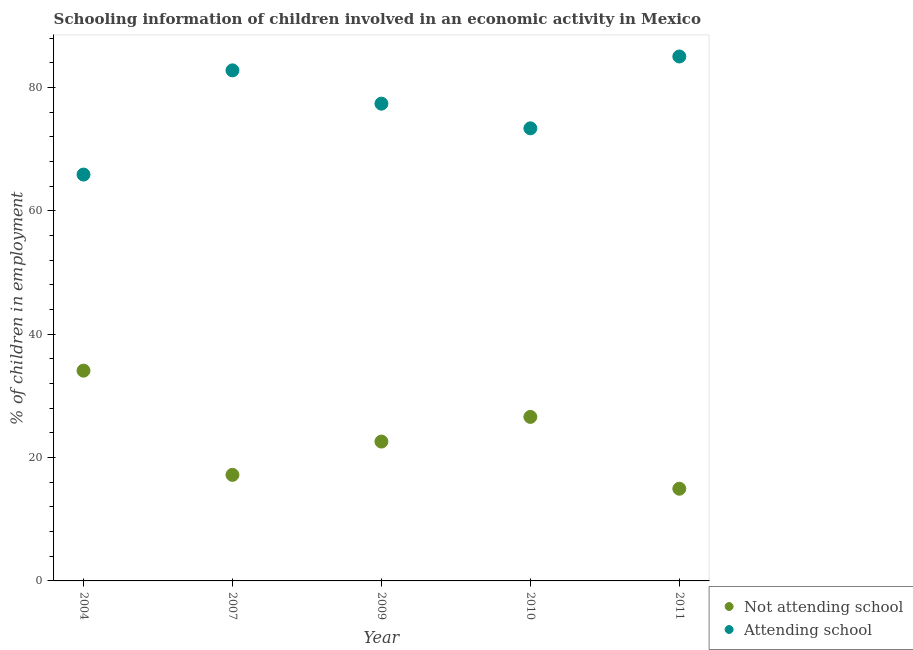How many different coloured dotlines are there?
Offer a very short reply. 2. Is the number of dotlines equal to the number of legend labels?
Ensure brevity in your answer.  Yes. What is the percentage of employed children who are not attending school in 2011?
Make the answer very short. 14.95. Across all years, what is the maximum percentage of employed children who are attending school?
Offer a terse response. 85.05. Across all years, what is the minimum percentage of employed children who are attending school?
Keep it short and to the point. 65.9. What is the total percentage of employed children who are attending school in the graph?
Your answer should be very brief. 384.55. What is the difference between the percentage of employed children who are not attending school in 2004 and that in 2007?
Offer a very short reply. 16.9. What is the difference between the percentage of employed children who are not attending school in 2010 and the percentage of employed children who are attending school in 2009?
Offer a very short reply. -50.8. What is the average percentage of employed children who are not attending school per year?
Your response must be concise. 23.09. In the year 2007, what is the difference between the percentage of employed children who are not attending school and percentage of employed children who are attending school?
Offer a very short reply. -65.6. In how many years, is the percentage of employed children who are attending school greater than 84 %?
Your answer should be compact. 1. What is the ratio of the percentage of employed children who are attending school in 2007 to that in 2009?
Your answer should be compact. 1.07. Is the percentage of employed children who are attending school in 2010 less than that in 2011?
Your answer should be very brief. Yes. What is the difference between the highest and the lowest percentage of employed children who are attending school?
Offer a very short reply. 19.15. Does the percentage of employed children who are attending school monotonically increase over the years?
Keep it short and to the point. No. Is the percentage of employed children who are attending school strictly less than the percentage of employed children who are not attending school over the years?
Your answer should be very brief. No. How many dotlines are there?
Ensure brevity in your answer.  2. How many years are there in the graph?
Offer a very short reply. 5. What is the difference between two consecutive major ticks on the Y-axis?
Provide a succinct answer. 20. Does the graph contain any zero values?
Provide a short and direct response. No. Does the graph contain grids?
Make the answer very short. No. What is the title of the graph?
Your answer should be very brief. Schooling information of children involved in an economic activity in Mexico. Does "Fraud firms" appear as one of the legend labels in the graph?
Offer a very short reply. No. What is the label or title of the X-axis?
Provide a short and direct response. Year. What is the label or title of the Y-axis?
Make the answer very short. % of children in employment. What is the % of children in employment of Not attending school in 2004?
Offer a very short reply. 34.1. What is the % of children in employment in Attending school in 2004?
Ensure brevity in your answer.  65.9. What is the % of children in employment of Not attending school in 2007?
Offer a terse response. 17.2. What is the % of children in employment of Attending school in 2007?
Your answer should be compact. 82.8. What is the % of children in employment in Not attending school in 2009?
Make the answer very short. 22.6. What is the % of children in employment in Attending school in 2009?
Provide a succinct answer. 77.4. What is the % of children in employment of Not attending school in 2010?
Your answer should be compact. 26.6. What is the % of children in employment of Attending school in 2010?
Offer a terse response. 73.4. What is the % of children in employment of Not attending school in 2011?
Ensure brevity in your answer.  14.95. What is the % of children in employment of Attending school in 2011?
Offer a very short reply. 85.05. Across all years, what is the maximum % of children in employment in Not attending school?
Your answer should be compact. 34.1. Across all years, what is the maximum % of children in employment in Attending school?
Provide a short and direct response. 85.05. Across all years, what is the minimum % of children in employment of Not attending school?
Ensure brevity in your answer.  14.95. Across all years, what is the minimum % of children in employment of Attending school?
Provide a succinct answer. 65.9. What is the total % of children in employment in Not attending school in the graph?
Provide a succinct answer. 115.45. What is the total % of children in employment in Attending school in the graph?
Offer a terse response. 384.55. What is the difference between the % of children in employment in Attending school in 2004 and that in 2007?
Offer a terse response. -16.9. What is the difference between the % of children in employment in Not attending school in 2004 and that in 2010?
Your answer should be very brief. 7.5. What is the difference between the % of children in employment of Attending school in 2004 and that in 2010?
Offer a terse response. -7.5. What is the difference between the % of children in employment of Not attending school in 2004 and that in 2011?
Your answer should be compact. 19.15. What is the difference between the % of children in employment of Attending school in 2004 and that in 2011?
Give a very brief answer. -19.15. What is the difference between the % of children in employment of Not attending school in 2007 and that in 2009?
Provide a succinct answer. -5.4. What is the difference between the % of children in employment in Not attending school in 2007 and that in 2011?
Keep it short and to the point. 2.25. What is the difference between the % of children in employment in Attending school in 2007 and that in 2011?
Provide a short and direct response. -2.25. What is the difference between the % of children in employment of Not attending school in 2009 and that in 2010?
Offer a terse response. -4. What is the difference between the % of children in employment of Not attending school in 2009 and that in 2011?
Make the answer very short. 7.65. What is the difference between the % of children in employment in Attending school in 2009 and that in 2011?
Provide a succinct answer. -7.65. What is the difference between the % of children in employment of Not attending school in 2010 and that in 2011?
Keep it short and to the point. 11.65. What is the difference between the % of children in employment of Attending school in 2010 and that in 2011?
Keep it short and to the point. -11.65. What is the difference between the % of children in employment of Not attending school in 2004 and the % of children in employment of Attending school in 2007?
Give a very brief answer. -48.7. What is the difference between the % of children in employment of Not attending school in 2004 and the % of children in employment of Attending school in 2009?
Your answer should be very brief. -43.3. What is the difference between the % of children in employment in Not attending school in 2004 and the % of children in employment in Attending school in 2010?
Make the answer very short. -39.3. What is the difference between the % of children in employment in Not attending school in 2004 and the % of children in employment in Attending school in 2011?
Provide a succinct answer. -50.95. What is the difference between the % of children in employment in Not attending school in 2007 and the % of children in employment in Attending school in 2009?
Provide a succinct answer. -60.2. What is the difference between the % of children in employment in Not attending school in 2007 and the % of children in employment in Attending school in 2010?
Your answer should be very brief. -56.2. What is the difference between the % of children in employment in Not attending school in 2007 and the % of children in employment in Attending school in 2011?
Provide a succinct answer. -67.85. What is the difference between the % of children in employment of Not attending school in 2009 and the % of children in employment of Attending school in 2010?
Provide a short and direct response. -50.8. What is the difference between the % of children in employment of Not attending school in 2009 and the % of children in employment of Attending school in 2011?
Make the answer very short. -62.45. What is the difference between the % of children in employment of Not attending school in 2010 and the % of children in employment of Attending school in 2011?
Your answer should be very brief. -58.45. What is the average % of children in employment of Not attending school per year?
Provide a short and direct response. 23.09. What is the average % of children in employment of Attending school per year?
Offer a terse response. 76.91. In the year 2004, what is the difference between the % of children in employment of Not attending school and % of children in employment of Attending school?
Offer a terse response. -31.8. In the year 2007, what is the difference between the % of children in employment in Not attending school and % of children in employment in Attending school?
Your answer should be very brief. -65.6. In the year 2009, what is the difference between the % of children in employment in Not attending school and % of children in employment in Attending school?
Provide a short and direct response. -54.8. In the year 2010, what is the difference between the % of children in employment of Not attending school and % of children in employment of Attending school?
Offer a very short reply. -46.8. In the year 2011, what is the difference between the % of children in employment in Not attending school and % of children in employment in Attending school?
Provide a succinct answer. -70.1. What is the ratio of the % of children in employment in Not attending school in 2004 to that in 2007?
Offer a very short reply. 1.98. What is the ratio of the % of children in employment of Attending school in 2004 to that in 2007?
Provide a succinct answer. 0.8. What is the ratio of the % of children in employment of Not attending school in 2004 to that in 2009?
Your answer should be compact. 1.51. What is the ratio of the % of children in employment in Attending school in 2004 to that in 2009?
Provide a succinct answer. 0.85. What is the ratio of the % of children in employment of Not attending school in 2004 to that in 2010?
Your answer should be very brief. 1.28. What is the ratio of the % of children in employment of Attending school in 2004 to that in 2010?
Give a very brief answer. 0.9. What is the ratio of the % of children in employment of Not attending school in 2004 to that in 2011?
Ensure brevity in your answer.  2.28. What is the ratio of the % of children in employment in Attending school in 2004 to that in 2011?
Give a very brief answer. 0.77. What is the ratio of the % of children in employment of Not attending school in 2007 to that in 2009?
Ensure brevity in your answer.  0.76. What is the ratio of the % of children in employment in Attending school in 2007 to that in 2009?
Make the answer very short. 1.07. What is the ratio of the % of children in employment of Not attending school in 2007 to that in 2010?
Your answer should be compact. 0.65. What is the ratio of the % of children in employment in Attending school in 2007 to that in 2010?
Ensure brevity in your answer.  1.13. What is the ratio of the % of children in employment in Not attending school in 2007 to that in 2011?
Ensure brevity in your answer.  1.15. What is the ratio of the % of children in employment of Attending school in 2007 to that in 2011?
Offer a very short reply. 0.97. What is the ratio of the % of children in employment of Not attending school in 2009 to that in 2010?
Your response must be concise. 0.85. What is the ratio of the % of children in employment in Attending school in 2009 to that in 2010?
Make the answer very short. 1.05. What is the ratio of the % of children in employment in Not attending school in 2009 to that in 2011?
Offer a terse response. 1.51. What is the ratio of the % of children in employment of Attending school in 2009 to that in 2011?
Keep it short and to the point. 0.91. What is the ratio of the % of children in employment in Not attending school in 2010 to that in 2011?
Ensure brevity in your answer.  1.78. What is the ratio of the % of children in employment in Attending school in 2010 to that in 2011?
Your response must be concise. 0.86. What is the difference between the highest and the second highest % of children in employment in Attending school?
Give a very brief answer. 2.25. What is the difference between the highest and the lowest % of children in employment in Not attending school?
Ensure brevity in your answer.  19.15. What is the difference between the highest and the lowest % of children in employment of Attending school?
Your answer should be compact. 19.15. 